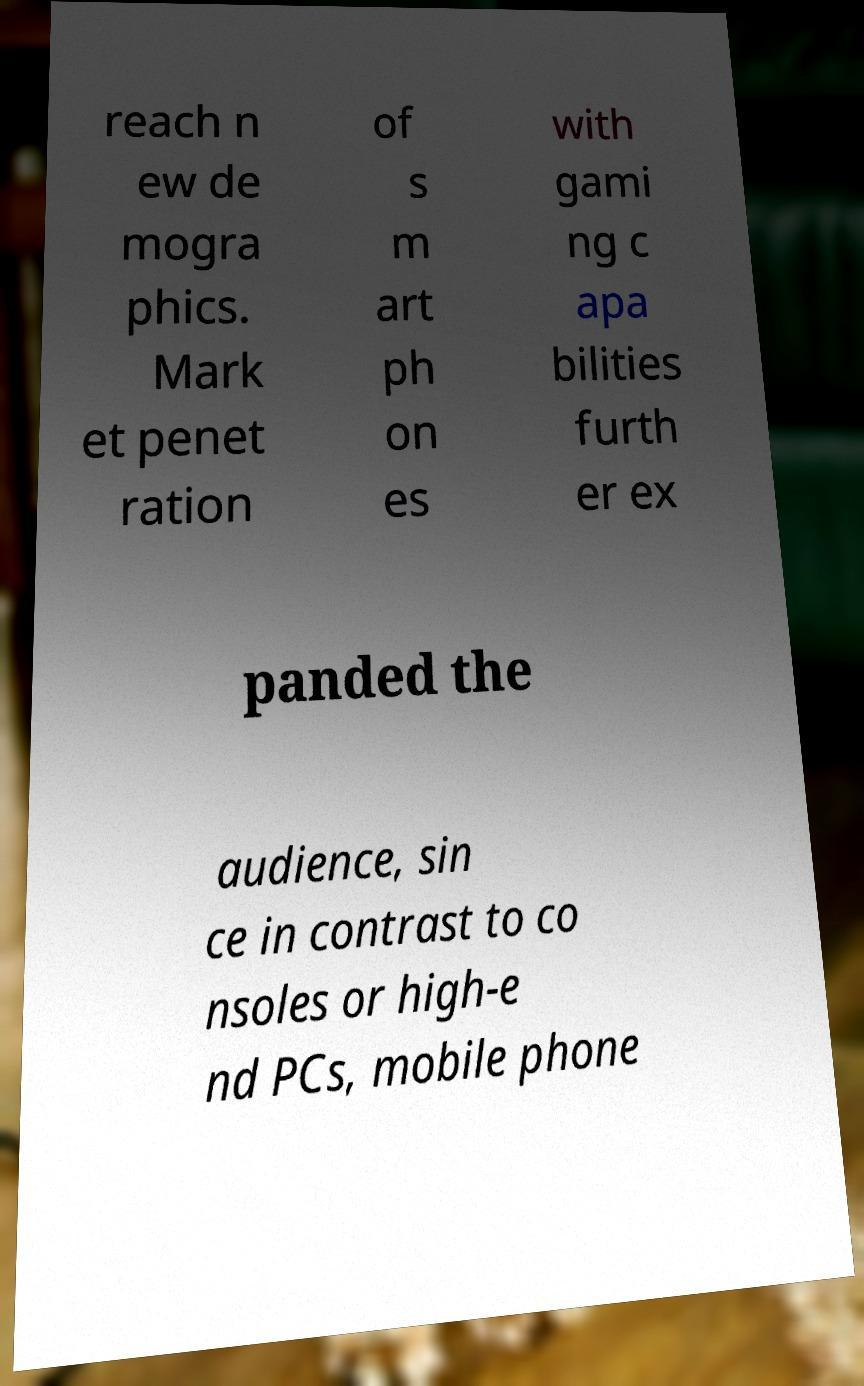For documentation purposes, I need the text within this image transcribed. Could you provide that? reach n ew de mogra phics. Mark et penet ration of s m art ph on es with gami ng c apa bilities furth er ex panded the audience, sin ce in contrast to co nsoles or high-e nd PCs, mobile phone 